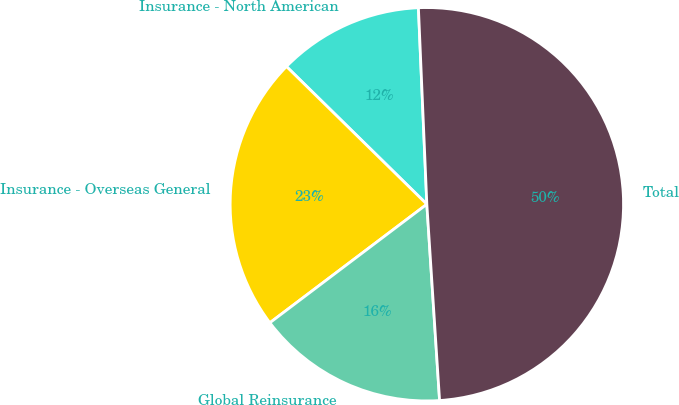<chart> <loc_0><loc_0><loc_500><loc_500><pie_chart><fcel>Insurance - North American<fcel>Insurance - Overseas General<fcel>Global Reinsurance<fcel>Total<nl><fcel>11.97%<fcel>22.64%<fcel>15.74%<fcel>49.65%<nl></chart> 